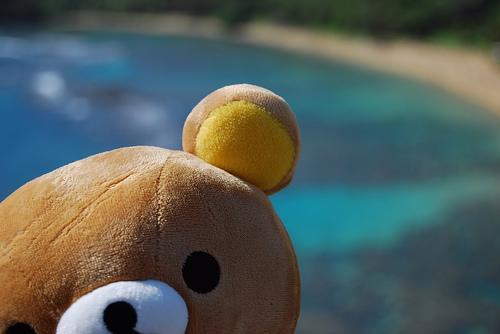Can you see the bear's mouth?
Answer briefly. No. What color are the bears eyes?
Short answer required. Black. Is this a stuffed animal?
Concise answer only. Yes. 